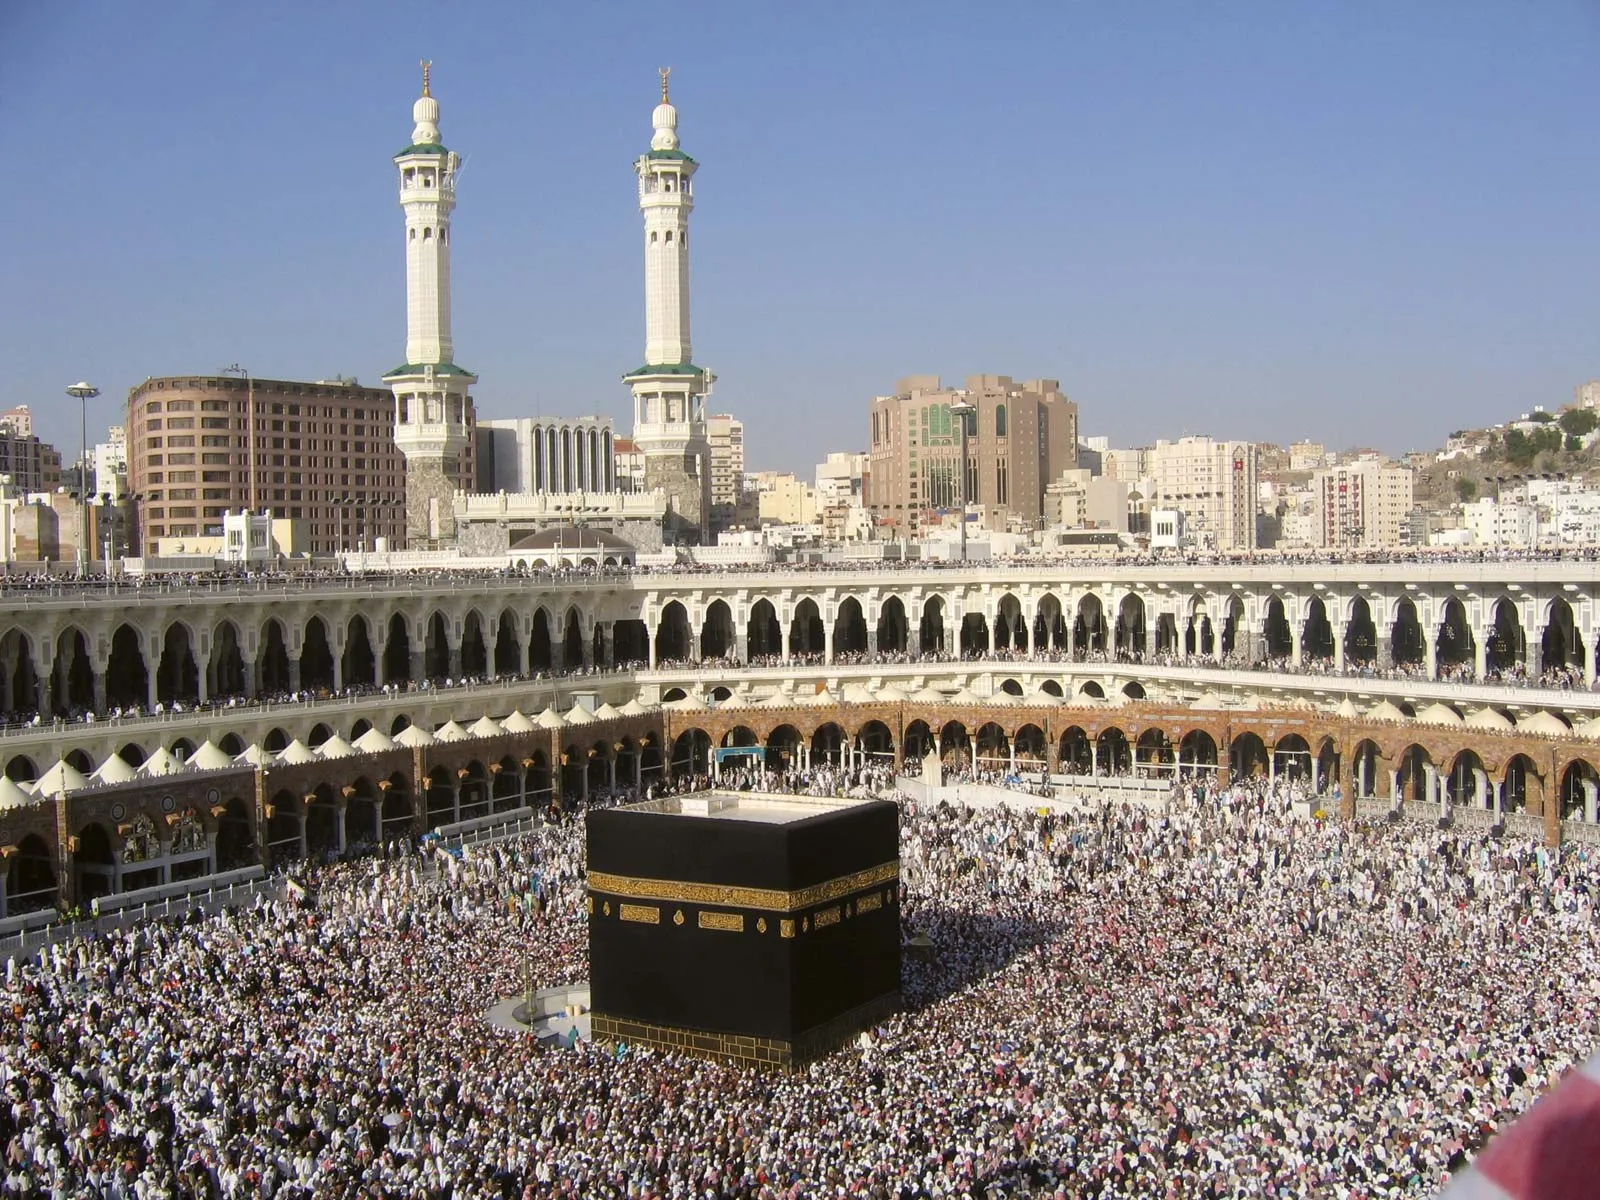What do you think is going on in this snapshot? This photograph captures a vibrant scene of worship at the Kaaba in Mecca, the holiest site in Islam. Visible is the cube-shaped Kaaba centrally located and draped in its distinctive black cloth with gold embroidery, symbolizing its sanctity. The massive gathering of pilgrims, uniformly dressed in white, suggests this photo was taken during Hajj, one of Islam's pivotal annual pilgrimages. Pilgrims perform the Tawaf, ritually circling the Kaaba seven times in a counterclockwise direction, which is vividly depicted as a dynamic swirl of activity. Architecturally, the scene is framed by elegant columned arcades and towering minarets, characteristic of Islamic design. The blend of historical reverence and contemporary participation shown here spotlights both the spiritual and communal aspects of this sacred ritual. 